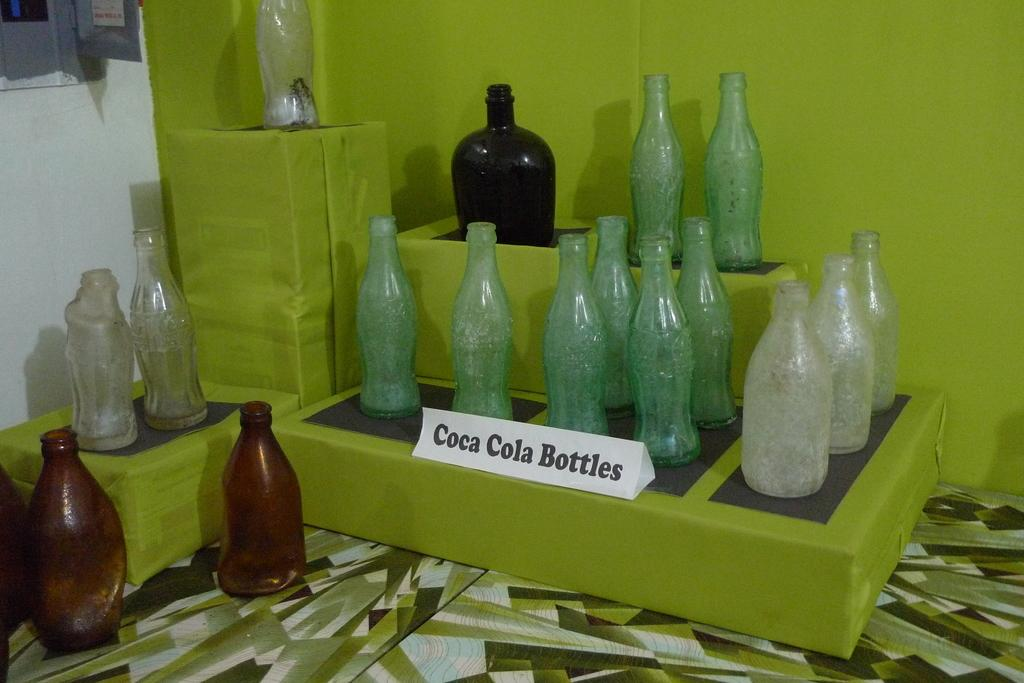<image>
Share a concise interpretation of the image provided. A display of old coca cola bottles on some green boxes. 